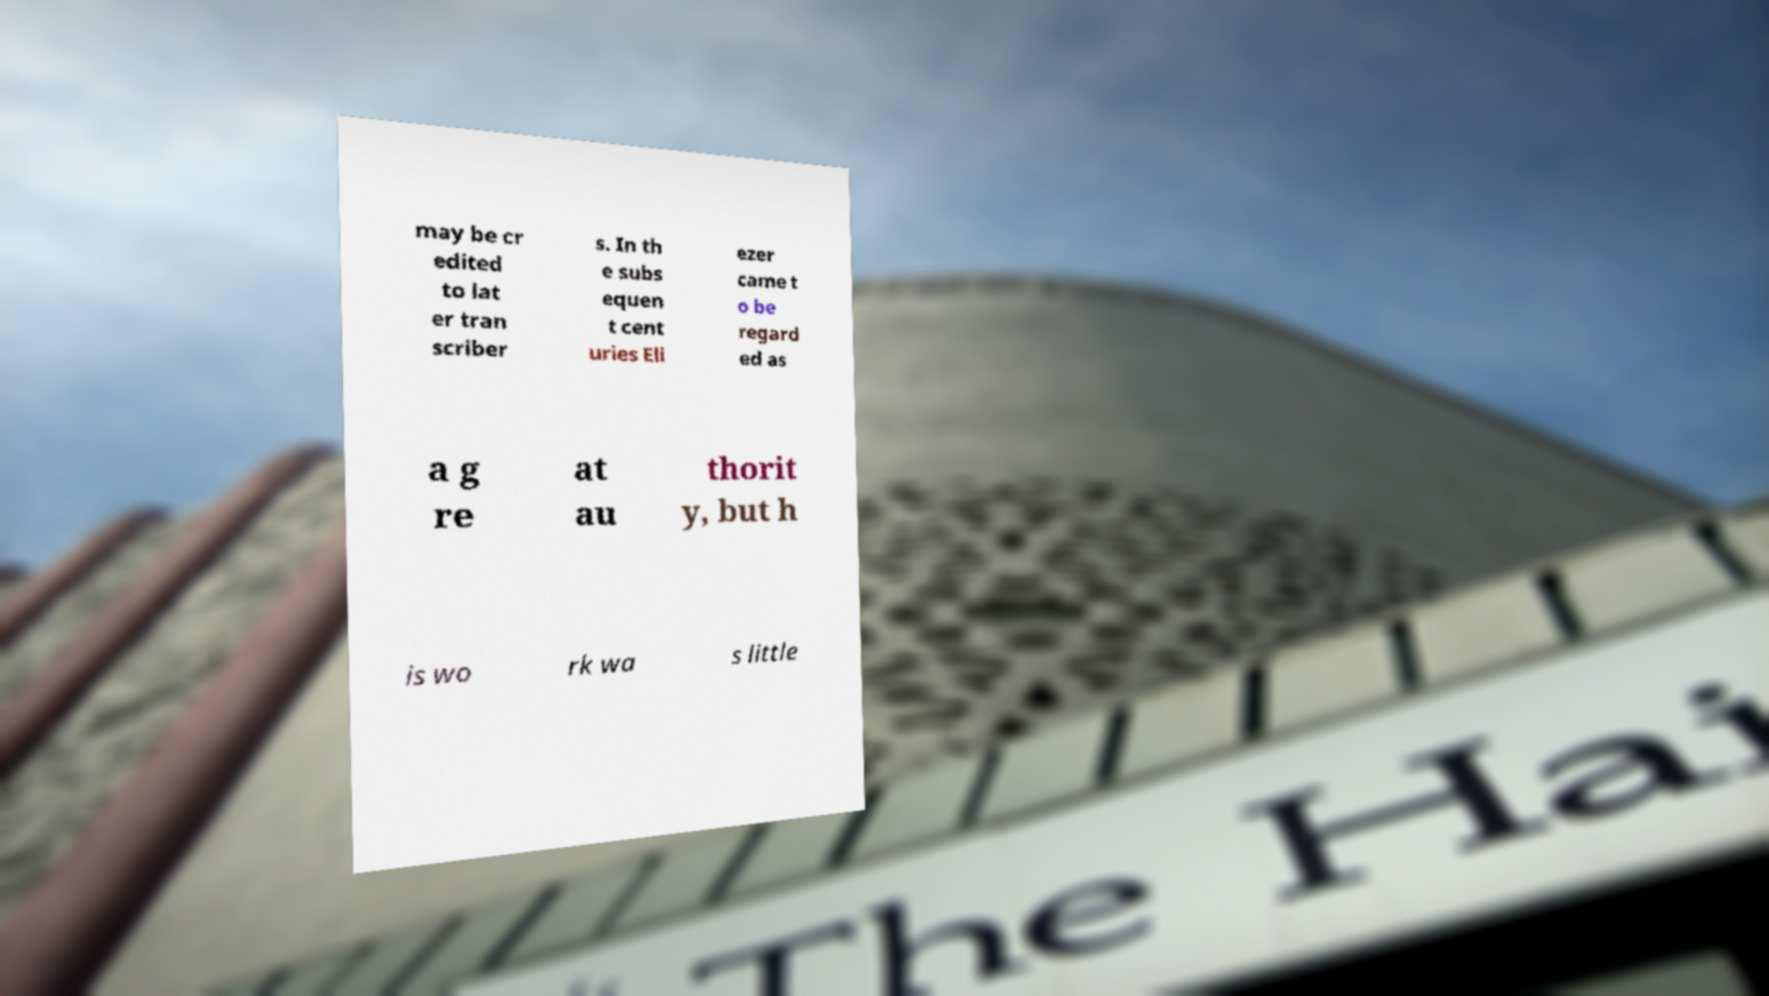Please identify and transcribe the text found in this image. may be cr edited to lat er tran scriber s. In th e subs equen t cent uries Eli ezer came t o be regard ed as a g re at au thorit y, but h is wo rk wa s little 